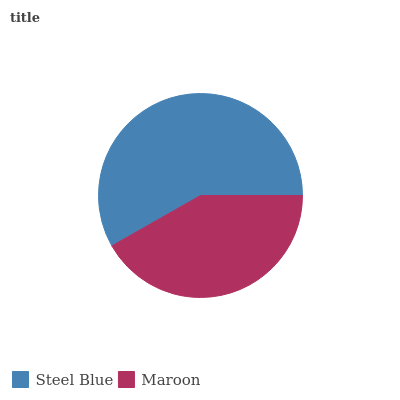Is Maroon the minimum?
Answer yes or no. Yes. Is Steel Blue the maximum?
Answer yes or no. Yes. Is Maroon the maximum?
Answer yes or no. No. Is Steel Blue greater than Maroon?
Answer yes or no. Yes. Is Maroon less than Steel Blue?
Answer yes or no. Yes. Is Maroon greater than Steel Blue?
Answer yes or no. No. Is Steel Blue less than Maroon?
Answer yes or no. No. Is Steel Blue the high median?
Answer yes or no. Yes. Is Maroon the low median?
Answer yes or no. Yes. Is Maroon the high median?
Answer yes or no. No. Is Steel Blue the low median?
Answer yes or no. No. 